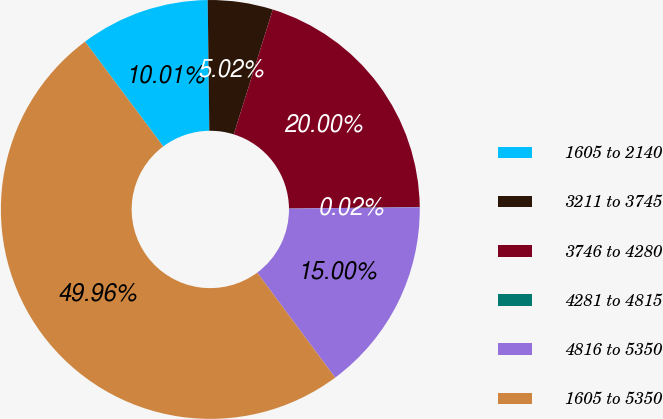Convert chart to OTSL. <chart><loc_0><loc_0><loc_500><loc_500><pie_chart><fcel>1605 to 2140<fcel>3211 to 3745<fcel>3746 to 4280<fcel>4281 to 4815<fcel>4816 to 5350<fcel>1605 to 5350<nl><fcel>10.01%<fcel>5.02%<fcel>20.0%<fcel>0.02%<fcel>15.0%<fcel>49.96%<nl></chart> 